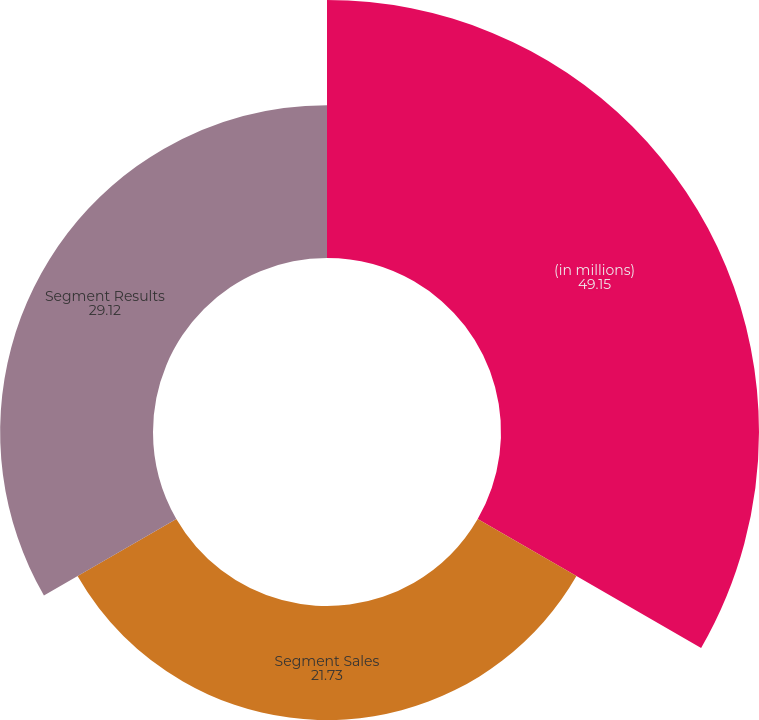Convert chart. <chart><loc_0><loc_0><loc_500><loc_500><pie_chart><fcel>(in millions)<fcel>Segment Sales<fcel>Segment Results<nl><fcel>49.15%<fcel>21.73%<fcel>29.12%<nl></chart> 